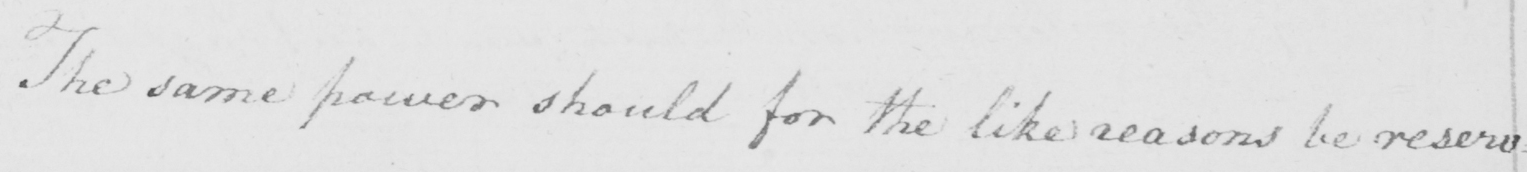Can you read and transcribe this handwriting? The same power should for the like reasons be reserv= 